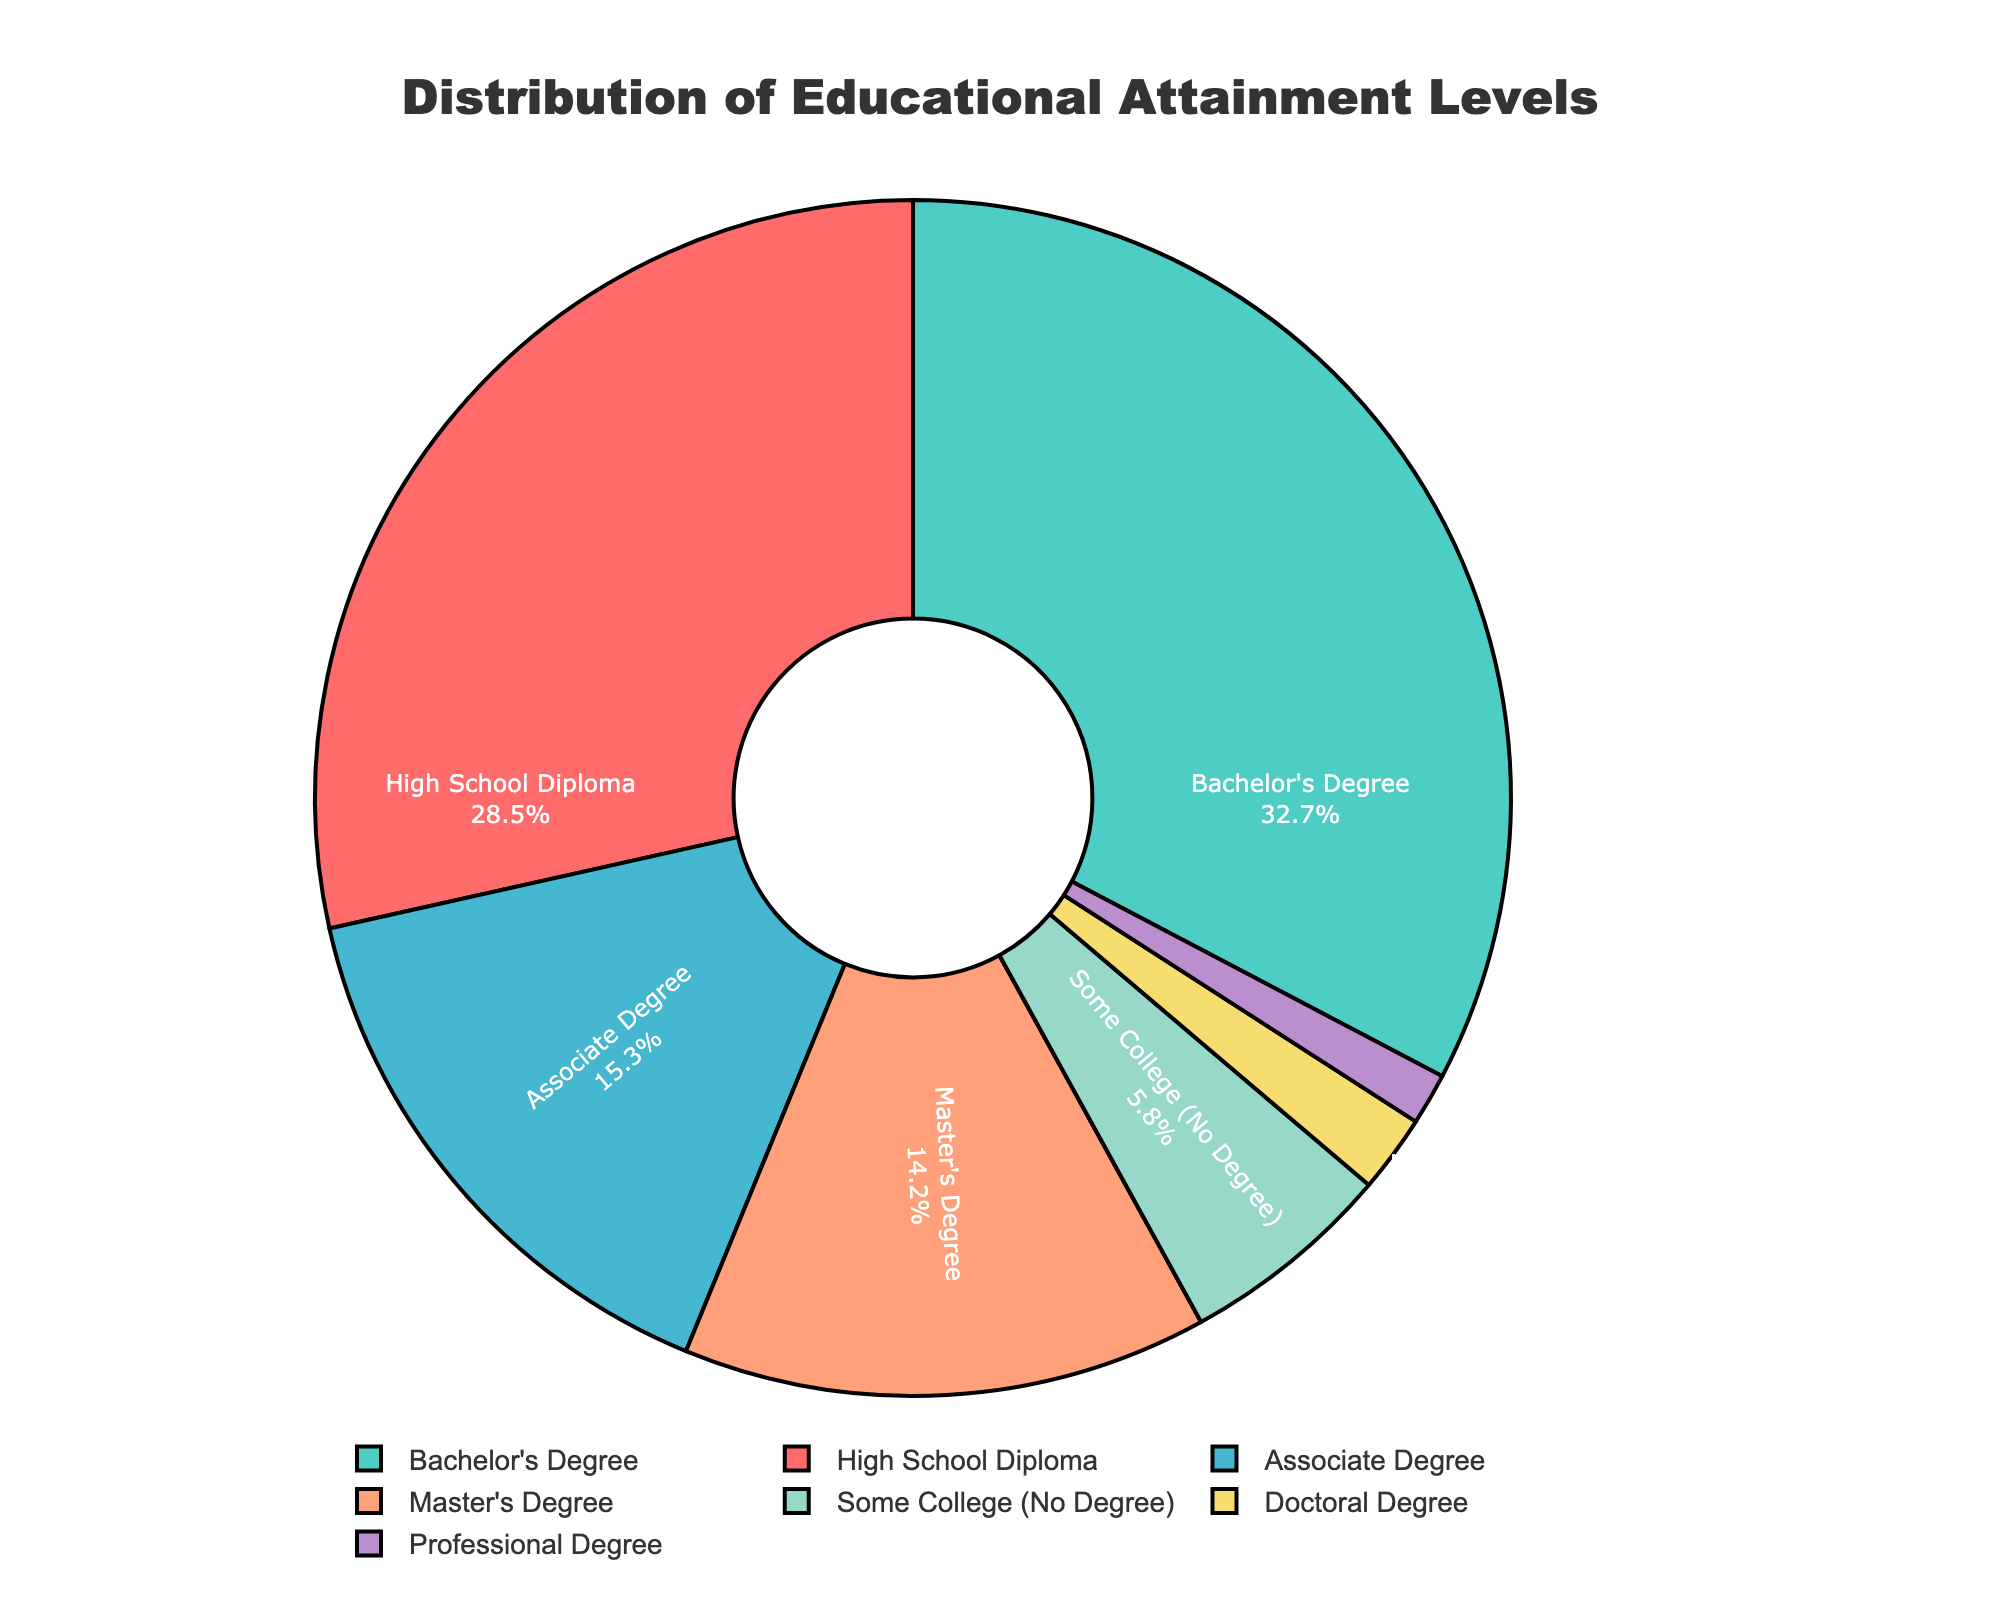What percentage of adults have attained at least a Bachelor's Degree? To determine the percentage of adults with at least a Bachelor's Degree, we sum the percentages of those with a Bachelor's Degree, Master's Degree, Doctoral Degree, or Professional Degree. The sum is 32.7% + 14.2% + 2.1% + 1.4% = 50.4%.
Answer: 50.4% Which educational level has the highest percentage of attainment, and what is that percentage? The educational level with the highest percentage of attainment can be identified by comparing the percentages shown in the pie chart. The Bachelor's Degree has the highest percentage, which is 32.7%.
Answer: Bachelor's Degree, 32.7% How does the percentage of adults with an Associate Degree compare to those with a Master's Degree? The percentage of adults with an Associate Degree is 15.3%, whereas the percentage of those with a Master's Degree is 14.2%. By comparing these values, we see that the percentage for the Associate Degree is slightly higher.
Answer: Associate Degree > Master's Degree What is the total percentage of adults who have not attained a Bachelor's Degree? To find this, we add the percentages of those with High School Diploma, Associate Degree, Some College (No Degree), Doctoral Degree, and Professional Degree. The sum is 28.5% + 15.3% + 5.8% + 2.1% + 1.4% = 53.1%.
Answer: 53.1% What is the difference in percentage between those with a High School Diploma and those with Some College (No Degree)? The percentage of adults with a High School Diploma is 28.5%, and those with Some College but no degree is 5.8%. The difference is 28.5% - 5.8% = 22.7%.
Answer: 22.7% Which educational levels have percentages below 10%, and what are they? Educational levels with percentages below 10% are identified as all levels with less than 10%. These are Some College (No Degree) with 5.8%, Doctoral Degree with 2.1%, and Professional Degree with 1.4%.
Answer: Some College (No Degree) 5.8%, Doctoral Degree 2.1%, Professional Degree 1.4% What is the combined percentage of adults with Doctoral and Professional Degrees? To find the combined percentage, simply add the percentages of adults with Doctoral and Professional Degrees, which is 2.1% + 1.4% = 3.5%.
Answer: 3.5% How many educational levels have attainment percentages greater than 15%? To determine this, identify and count levels with percentages greater than 15%. They are High School Diploma (28.5%), Bachelor's Degree (32.7%), and Associate Degree (15.3%). There are 3 levels.
Answer: 3 